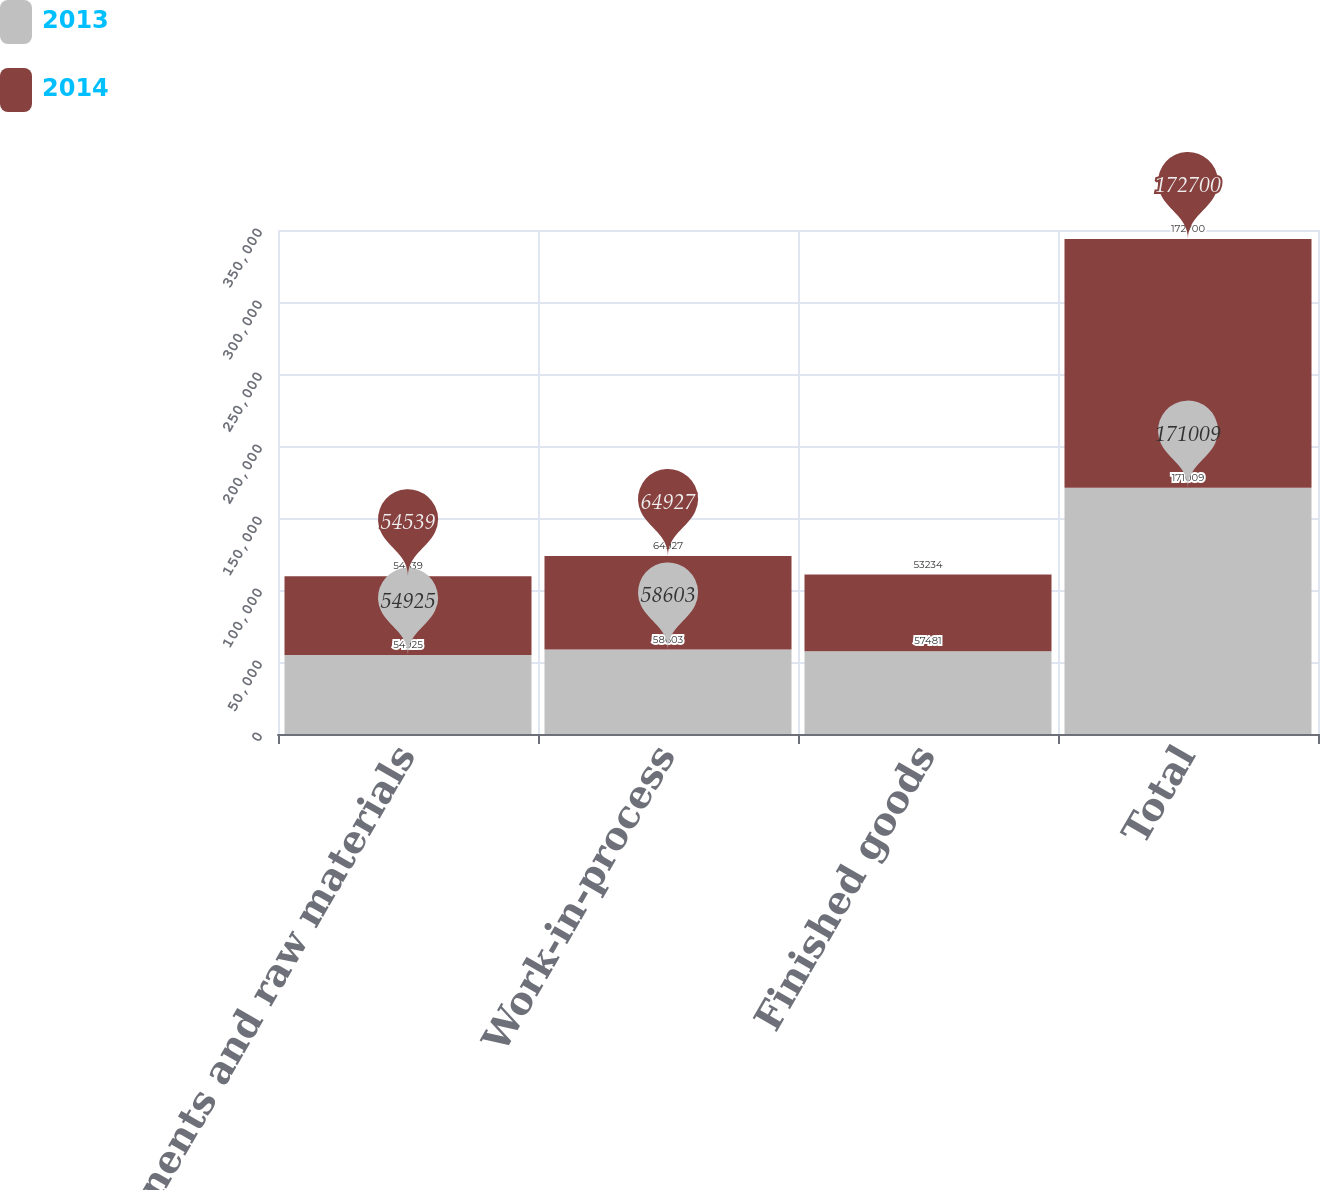Convert chart. <chart><loc_0><loc_0><loc_500><loc_500><stacked_bar_chart><ecel><fcel>Components and raw materials<fcel>Work-in-process<fcel>Finished goods<fcel>Total<nl><fcel>2013<fcel>54925<fcel>58603<fcel>57481<fcel>171009<nl><fcel>2014<fcel>54539<fcel>64927<fcel>53234<fcel>172700<nl></chart> 